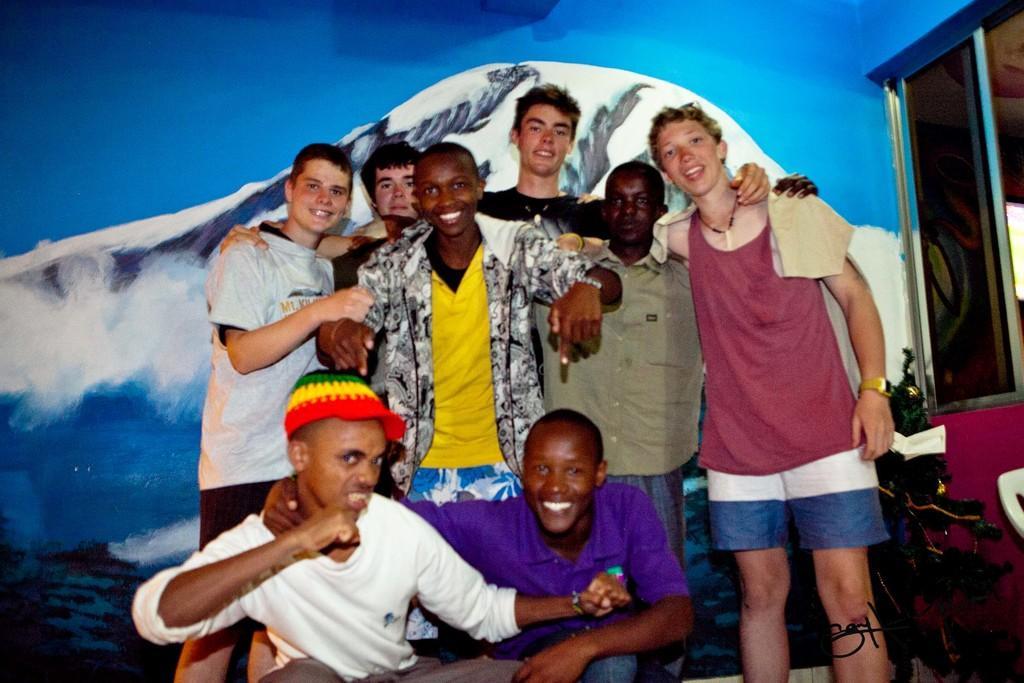Please provide a concise description of this image. In this image we can see a group of people smiling, behind them, we can see a painting on the wall and also we can see a plant and a window. 